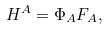<formula> <loc_0><loc_0><loc_500><loc_500>H ^ { A } = \Phi _ { A } F _ { A } ,</formula> 